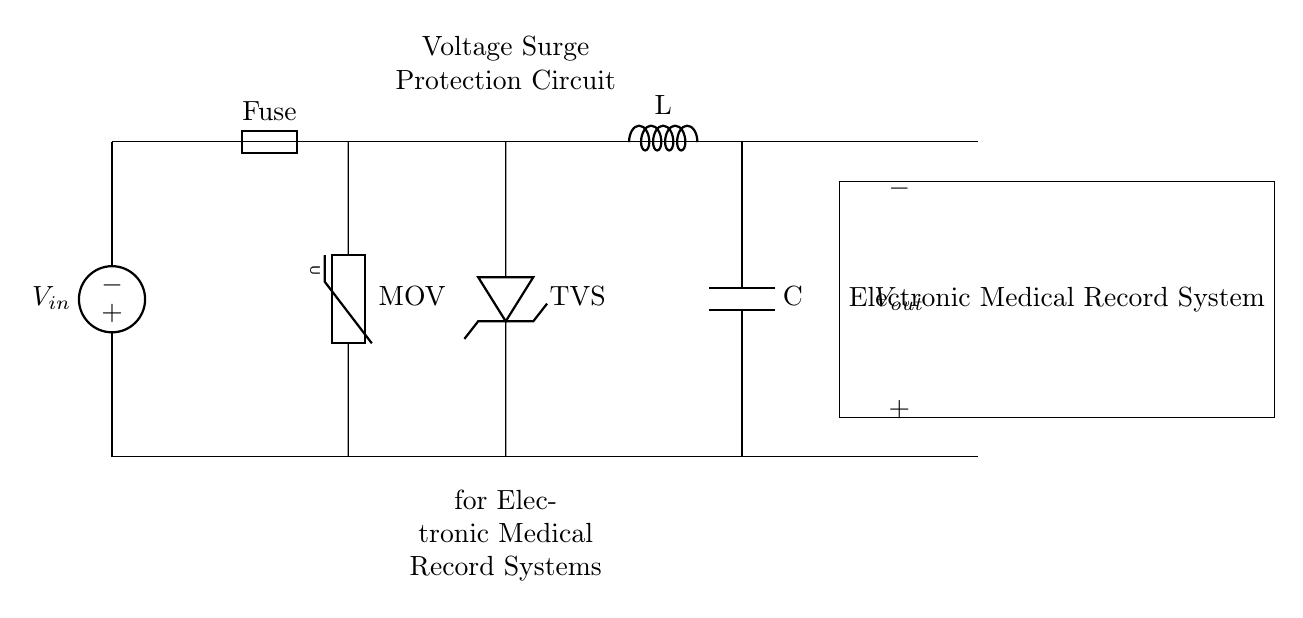What is the input voltage of the circuit? The input voltage is represented by the voltage source labeled V_in. This is the voltage supplied to the circuit, which is the starting point for the voltage surge protection.
Answer: V_in What component is used to protect against voltage surges? A Metal Oxide Varistor (MOV) is used for voltage surge protection. It is placed in parallel with the circuit to absorb excess voltage, thereby protecting sensitive components downstream.
Answer: MOV What does the TVS stand for in this circuit? TVS stands for Transient Voltage Suppressor. It is a protective device that clamps high voltage spikes to safe levels and is crucial for ensuring that the electronic medical record system remains operational during transient events.
Answer: Transient Voltage Suppressor How many major protection components are there in the circuit? The circuit includes three major protection components: the fuse, the MOV, and the TVS diode. These components work together to safeguard the circuit from voltage surges and unforeseen electrical issues.
Answer: Three What is the function of the LC filter? The LC filter, consisting of an inductor (L) and a capacitor (C), is used to smooth out voltage fluctuations and filter noise from the circuit. This contributes to the stability of the voltage supplied to the electronic medical record system.
Answer: Smoothing voltage fluctuations Where does the output voltage connect? The output voltage, labeled V_out, connects to the electronic medical record system. This is the final component that receives the surge-protected voltage for operation.
Answer: Electronic Medical Record System What role does the fuse play in the circuit? The fuse acts as a safety device that disconnects the circuit in the event of an overload or short circuit. This prevents excessive current that could damage the circuit components, thereby providing an essential safety mechanism.
Answer: Safety device 